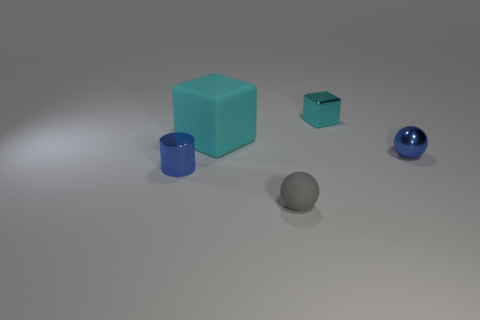Subtract all cylinders. How many objects are left? 4 Subtract 1 spheres. How many spheres are left? 1 Add 4 small metal blocks. How many objects exist? 9 Subtract all gray cylinders. Subtract all green cubes. How many cylinders are left? 1 Subtract all gray spheres. How many yellow blocks are left? 0 Subtract all things. Subtract all big gray cylinders. How many objects are left? 0 Add 5 cyan shiny cubes. How many cyan shiny cubes are left? 6 Add 3 cyan rubber cubes. How many cyan rubber cubes exist? 4 Subtract 0 yellow cylinders. How many objects are left? 5 